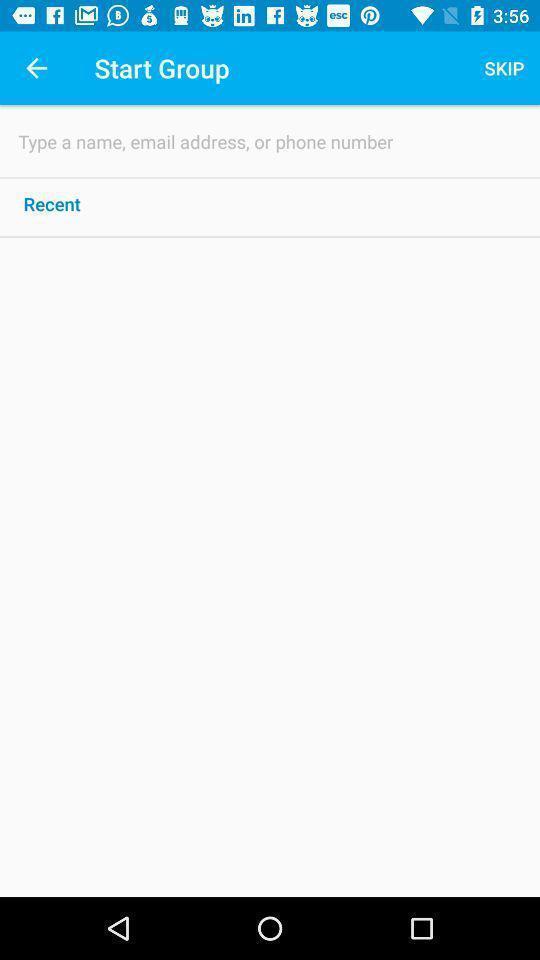Explain the elements present in this screenshot. Screen shows multiple options. 